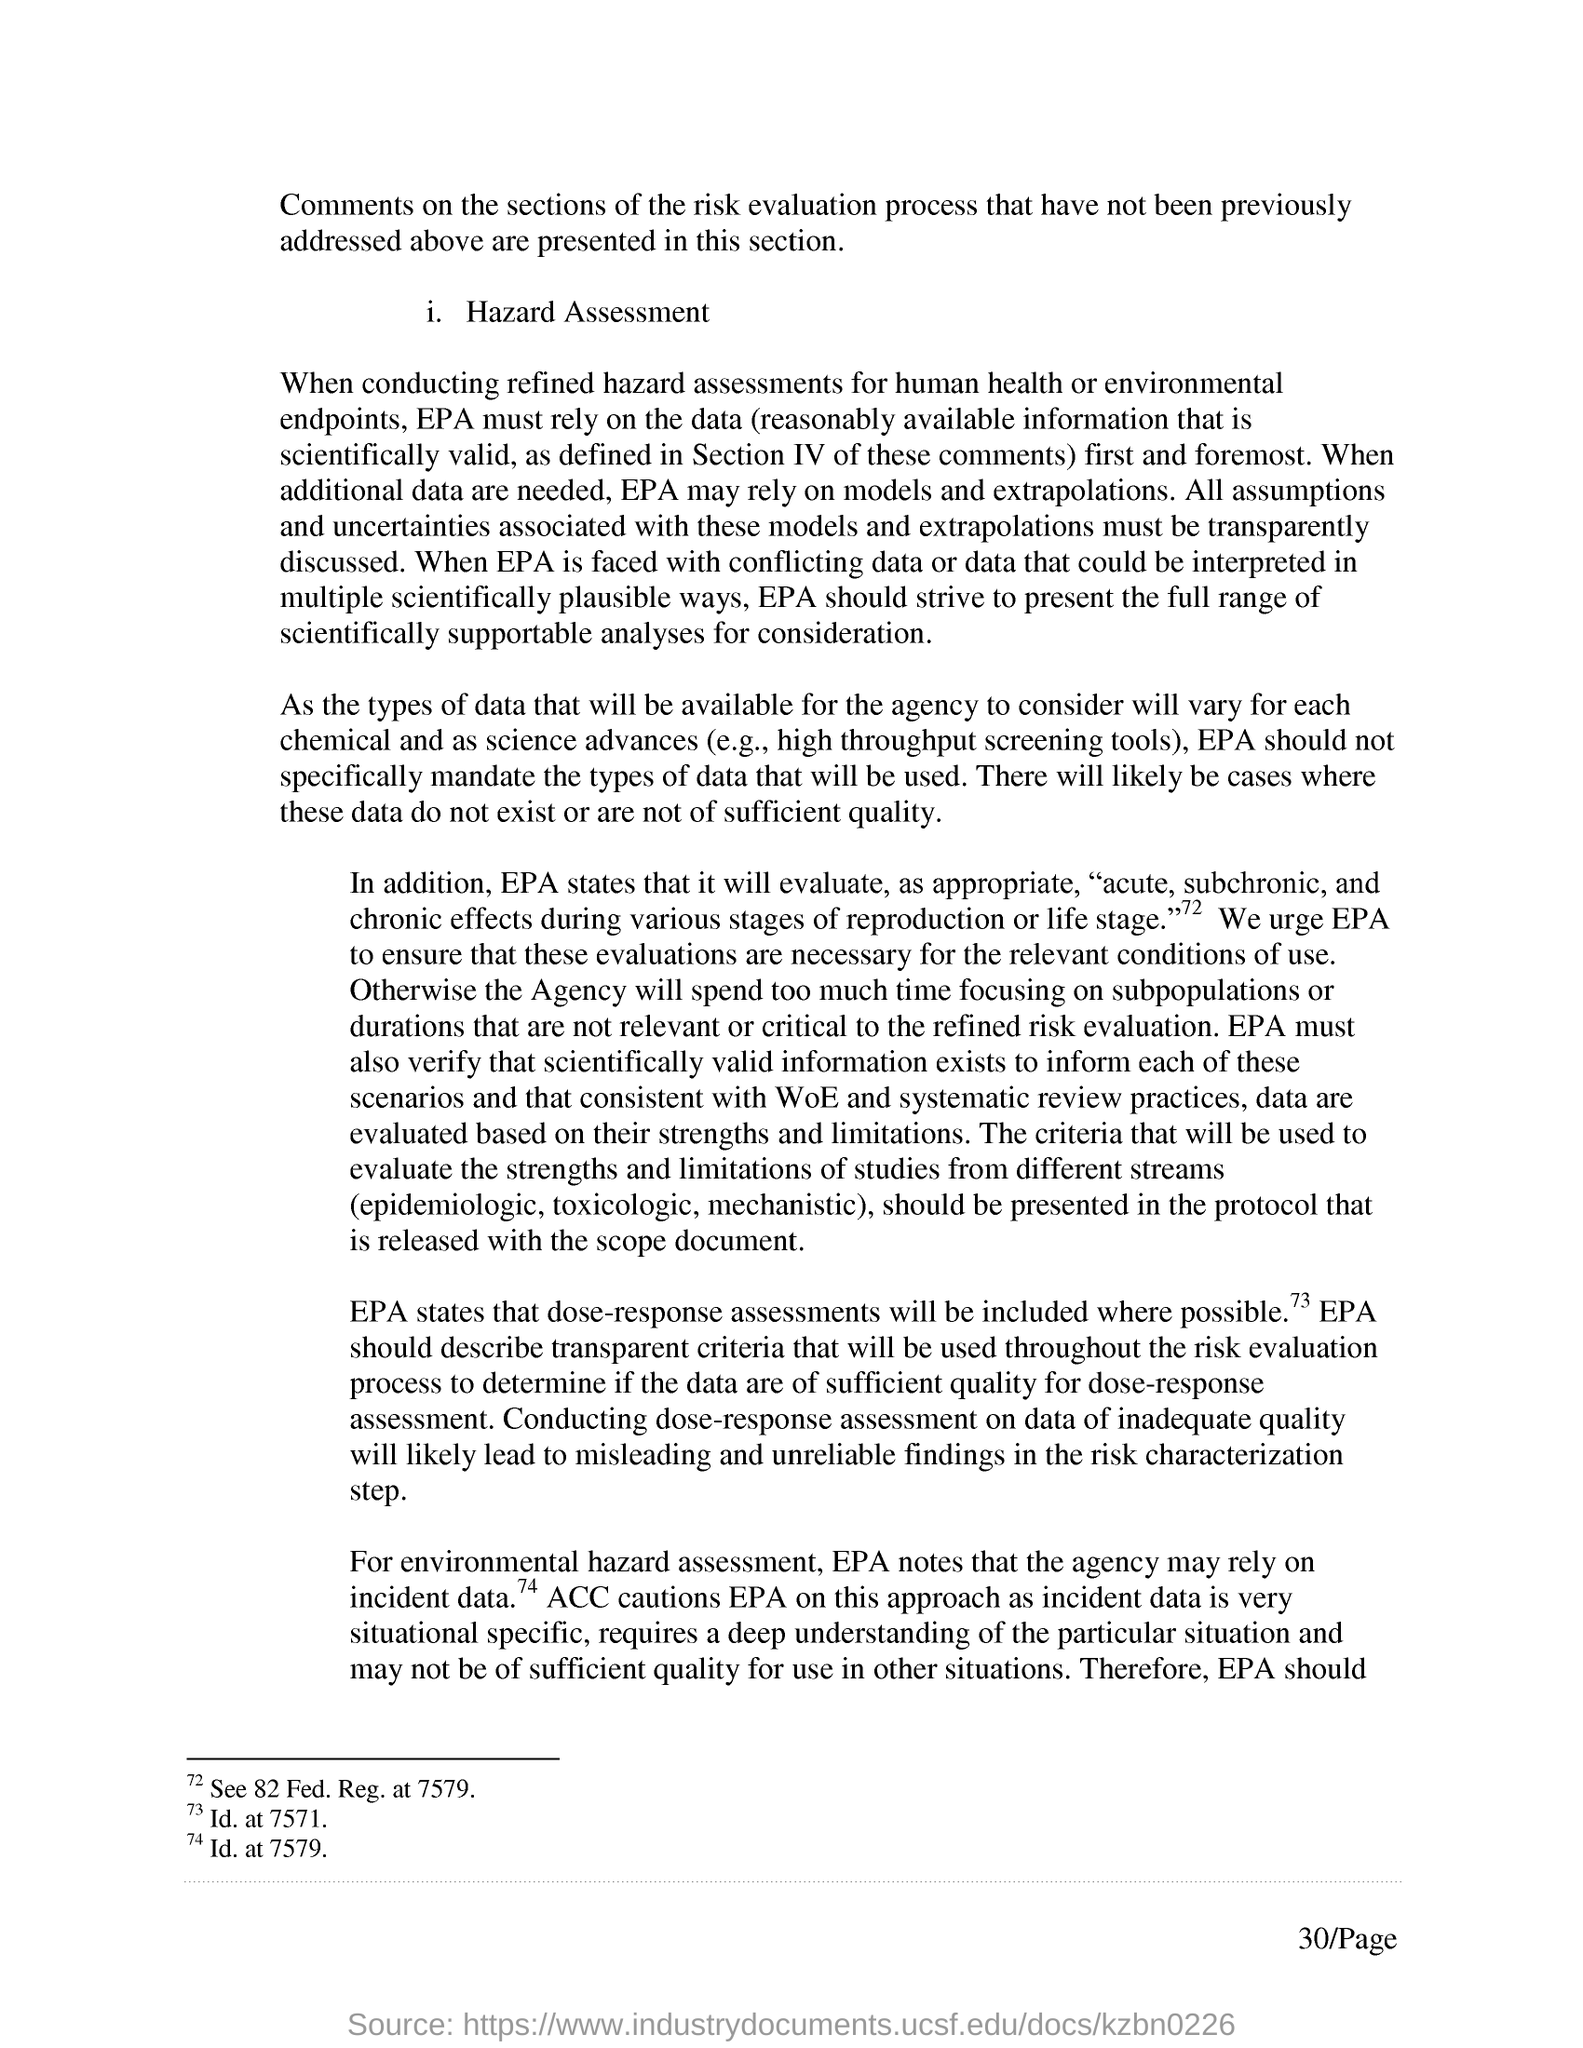List a handful of essential elements in this visual. The Environmental Protection Agency (EPA) may rely on models and extrapolations when in need of additional data. The page number mentioned in this document is 30.. 